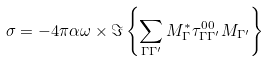Convert formula to latex. <formula><loc_0><loc_0><loc_500><loc_500>\sigma = - 4 \pi \alpha \omega \times \Im \left \{ \sum _ { \Gamma \Gamma ^ { \prime } } M _ { \Gamma } ^ { * } \tau ^ { 0 0 } _ { \Gamma \Gamma ^ { \prime } } M _ { \Gamma ^ { \prime } } \right \}</formula> 